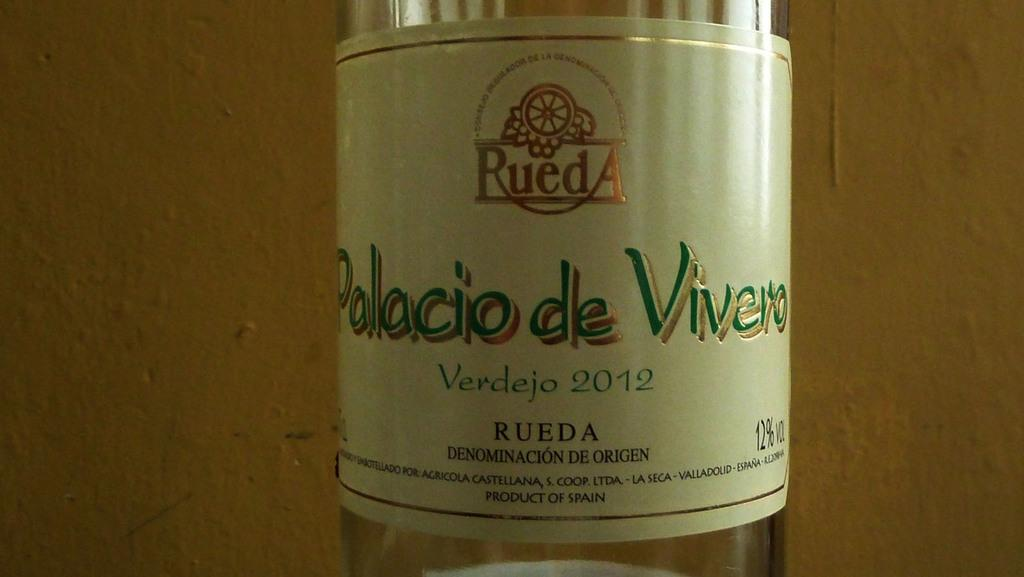<image>
Create a compact narrative representing the image presented. A clear bottle of Palacio de Vivero is from 2012. 